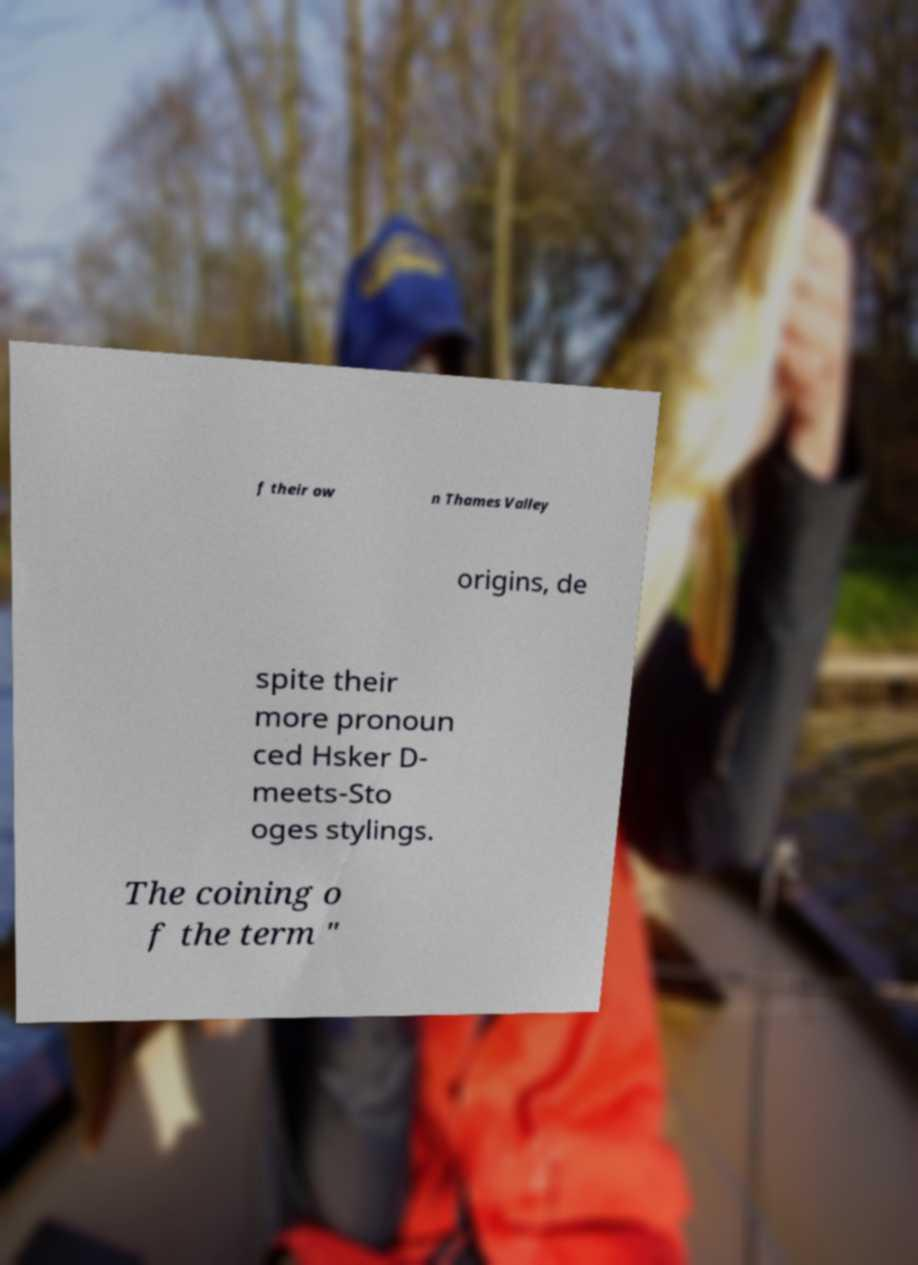Please read and relay the text visible in this image. What does it say? f their ow n Thames Valley origins, de spite their more pronoun ced Hsker D- meets-Sto oges stylings. The coining o f the term " 